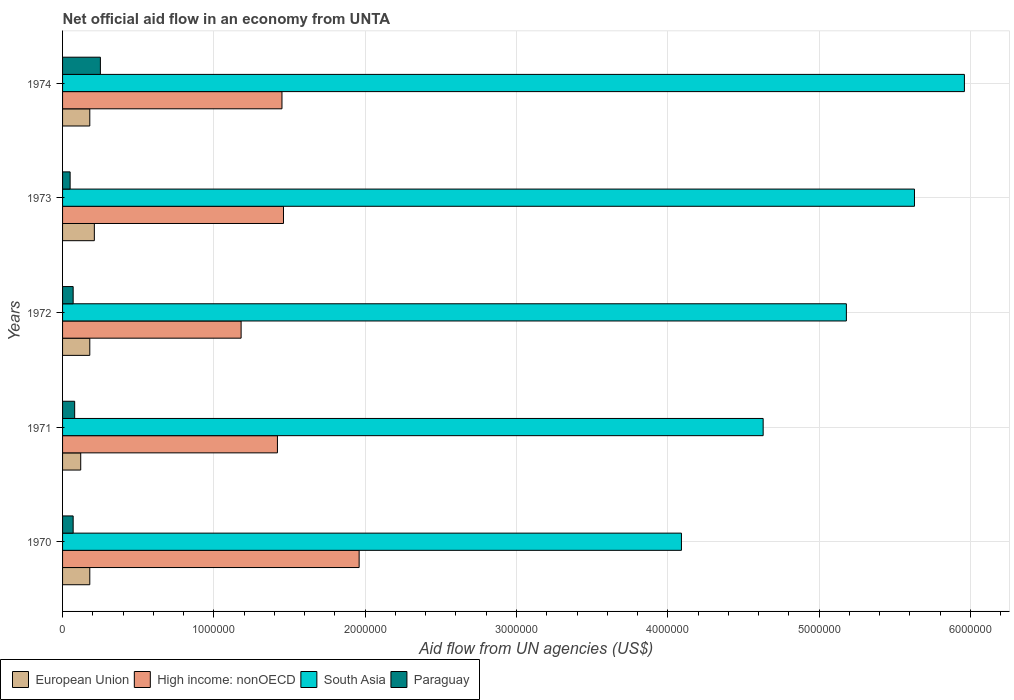How many different coloured bars are there?
Offer a terse response. 4. How many groups of bars are there?
Provide a succinct answer. 5. How many bars are there on the 5th tick from the top?
Provide a short and direct response. 4. What is the label of the 5th group of bars from the top?
Provide a short and direct response. 1970. In how many cases, is the number of bars for a given year not equal to the number of legend labels?
Your answer should be very brief. 0. Across all years, what is the maximum net official aid flow in South Asia?
Offer a terse response. 5.96e+06. In which year was the net official aid flow in European Union maximum?
Offer a terse response. 1973. In which year was the net official aid flow in South Asia minimum?
Keep it short and to the point. 1970. What is the total net official aid flow in South Asia in the graph?
Provide a succinct answer. 2.55e+07. What is the difference between the net official aid flow in High income: nonOECD in 1972 and that in 1974?
Your response must be concise. -2.70e+05. What is the difference between the net official aid flow in High income: nonOECD in 1970 and the net official aid flow in South Asia in 1972?
Your answer should be compact. -3.22e+06. What is the average net official aid flow in South Asia per year?
Give a very brief answer. 5.10e+06. In the year 1970, what is the difference between the net official aid flow in European Union and net official aid flow in South Asia?
Provide a short and direct response. -3.91e+06. What is the ratio of the net official aid flow in High income: nonOECD in 1971 to that in 1974?
Provide a succinct answer. 0.98. Is the difference between the net official aid flow in European Union in 1970 and 1972 greater than the difference between the net official aid flow in South Asia in 1970 and 1972?
Give a very brief answer. Yes. What is the difference between the highest and the second highest net official aid flow in Paraguay?
Your response must be concise. 1.70e+05. What is the difference between the highest and the lowest net official aid flow in High income: nonOECD?
Ensure brevity in your answer.  7.80e+05. In how many years, is the net official aid flow in Paraguay greater than the average net official aid flow in Paraguay taken over all years?
Keep it short and to the point. 1. Is the sum of the net official aid flow in South Asia in 1973 and 1974 greater than the maximum net official aid flow in Paraguay across all years?
Offer a terse response. Yes. Is it the case that in every year, the sum of the net official aid flow in High income: nonOECD and net official aid flow in South Asia is greater than the sum of net official aid flow in Paraguay and net official aid flow in European Union?
Provide a short and direct response. No. What does the 1st bar from the top in 1970 represents?
Your answer should be very brief. Paraguay. What does the 4th bar from the bottom in 1971 represents?
Provide a short and direct response. Paraguay. How many years are there in the graph?
Keep it short and to the point. 5. Are the values on the major ticks of X-axis written in scientific E-notation?
Offer a terse response. No. Does the graph contain grids?
Make the answer very short. Yes. Where does the legend appear in the graph?
Provide a short and direct response. Bottom left. What is the title of the graph?
Keep it short and to the point. Net official aid flow in an economy from UNTA. What is the label or title of the X-axis?
Your response must be concise. Aid flow from UN agencies (US$). What is the Aid flow from UN agencies (US$) in High income: nonOECD in 1970?
Your answer should be compact. 1.96e+06. What is the Aid flow from UN agencies (US$) of South Asia in 1970?
Offer a very short reply. 4.09e+06. What is the Aid flow from UN agencies (US$) of High income: nonOECD in 1971?
Provide a short and direct response. 1.42e+06. What is the Aid flow from UN agencies (US$) of South Asia in 1971?
Offer a very short reply. 4.63e+06. What is the Aid flow from UN agencies (US$) of Paraguay in 1971?
Offer a very short reply. 8.00e+04. What is the Aid flow from UN agencies (US$) in European Union in 1972?
Your answer should be compact. 1.80e+05. What is the Aid flow from UN agencies (US$) of High income: nonOECD in 1972?
Your answer should be compact. 1.18e+06. What is the Aid flow from UN agencies (US$) of South Asia in 1972?
Your response must be concise. 5.18e+06. What is the Aid flow from UN agencies (US$) of High income: nonOECD in 1973?
Provide a succinct answer. 1.46e+06. What is the Aid flow from UN agencies (US$) in South Asia in 1973?
Provide a short and direct response. 5.63e+06. What is the Aid flow from UN agencies (US$) in European Union in 1974?
Your response must be concise. 1.80e+05. What is the Aid flow from UN agencies (US$) in High income: nonOECD in 1974?
Make the answer very short. 1.45e+06. What is the Aid flow from UN agencies (US$) of South Asia in 1974?
Offer a terse response. 5.96e+06. What is the Aid flow from UN agencies (US$) of Paraguay in 1974?
Make the answer very short. 2.50e+05. Across all years, what is the maximum Aid flow from UN agencies (US$) in European Union?
Your answer should be very brief. 2.10e+05. Across all years, what is the maximum Aid flow from UN agencies (US$) in High income: nonOECD?
Give a very brief answer. 1.96e+06. Across all years, what is the maximum Aid flow from UN agencies (US$) of South Asia?
Ensure brevity in your answer.  5.96e+06. Across all years, what is the minimum Aid flow from UN agencies (US$) in European Union?
Keep it short and to the point. 1.20e+05. Across all years, what is the minimum Aid flow from UN agencies (US$) of High income: nonOECD?
Make the answer very short. 1.18e+06. Across all years, what is the minimum Aid flow from UN agencies (US$) in South Asia?
Ensure brevity in your answer.  4.09e+06. Across all years, what is the minimum Aid flow from UN agencies (US$) of Paraguay?
Your answer should be very brief. 5.00e+04. What is the total Aid flow from UN agencies (US$) of European Union in the graph?
Give a very brief answer. 8.70e+05. What is the total Aid flow from UN agencies (US$) in High income: nonOECD in the graph?
Provide a short and direct response. 7.47e+06. What is the total Aid flow from UN agencies (US$) of South Asia in the graph?
Provide a short and direct response. 2.55e+07. What is the total Aid flow from UN agencies (US$) in Paraguay in the graph?
Your answer should be compact. 5.20e+05. What is the difference between the Aid flow from UN agencies (US$) of High income: nonOECD in 1970 and that in 1971?
Ensure brevity in your answer.  5.40e+05. What is the difference between the Aid flow from UN agencies (US$) in South Asia in 1970 and that in 1971?
Offer a very short reply. -5.40e+05. What is the difference between the Aid flow from UN agencies (US$) in Paraguay in 1970 and that in 1971?
Give a very brief answer. -10000. What is the difference between the Aid flow from UN agencies (US$) of European Union in 1970 and that in 1972?
Your answer should be compact. 0. What is the difference between the Aid flow from UN agencies (US$) of High income: nonOECD in 1970 and that in 1972?
Offer a very short reply. 7.80e+05. What is the difference between the Aid flow from UN agencies (US$) of South Asia in 1970 and that in 1972?
Provide a short and direct response. -1.09e+06. What is the difference between the Aid flow from UN agencies (US$) of Paraguay in 1970 and that in 1972?
Provide a short and direct response. 0. What is the difference between the Aid flow from UN agencies (US$) in European Union in 1970 and that in 1973?
Your answer should be very brief. -3.00e+04. What is the difference between the Aid flow from UN agencies (US$) of High income: nonOECD in 1970 and that in 1973?
Provide a succinct answer. 5.00e+05. What is the difference between the Aid flow from UN agencies (US$) in South Asia in 1970 and that in 1973?
Offer a terse response. -1.54e+06. What is the difference between the Aid flow from UN agencies (US$) of High income: nonOECD in 1970 and that in 1974?
Provide a short and direct response. 5.10e+05. What is the difference between the Aid flow from UN agencies (US$) in South Asia in 1970 and that in 1974?
Provide a short and direct response. -1.87e+06. What is the difference between the Aid flow from UN agencies (US$) of Paraguay in 1970 and that in 1974?
Provide a short and direct response. -1.80e+05. What is the difference between the Aid flow from UN agencies (US$) in South Asia in 1971 and that in 1972?
Offer a terse response. -5.50e+05. What is the difference between the Aid flow from UN agencies (US$) of Paraguay in 1971 and that in 1972?
Your answer should be very brief. 10000. What is the difference between the Aid flow from UN agencies (US$) of European Union in 1971 and that in 1974?
Provide a succinct answer. -6.00e+04. What is the difference between the Aid flow from UN agencies (US$) of South Asia in 1971 and that in 1974?
Give a very brief answer. -1.33e+06. What is the difference between the Aid flow from UN agencies (US$) of High income: nonOECD in 1972 and that in 1973?
Your answer should be compact. -2.80e+05. What is the difference between the Aid flow from UN agencies (US$) of South Asia in 1972 and that in 1973?
Make the answer very short. -4.50e+05. What is the difference between the Aid flow from UN agencies (US$) of Paraguay in 1972 and that in 1973?
Your answer should be very brief. 2.00e+04. What is the difference between the Aid flow from UN agencies (US$) of South Asia in 1972 and that in 1974?
Offer a very short reply. -7.80e+05. What is the difference between the Aid flow from UN agencies (US$) of Paraguay in 1972 and that in 1974?
Your response must be concise. -1.80e+05. What is the difference between the Aid flow from UN agencies (US$) of High income: nonOECD in 1973 and that in 1974?
Offer a terse response. 10000. What is the difference between the Aid flow from UN agencies (US$) in South Asia in 1973 and that in 1974?
Offer a terse response. -3.30e+05. What is the difference between the Aid flow from UN agencies (US$) in European Union in 1970 and the Aid flow from UN agencies (US$) in High income: nonOECD in 1971?
Ensure brevity in your answer.  -1.24e+06. What is the difference between the Aid flow from UN agencies (US$) in European Union in 1970 and the Aid flow from UN agencies (US$) in South Asia in 1971?
Provide a succinct answer. -4.45e+06. What is the difference between the Aid flow from UN agencies (US$) in European Union in 1970 and the Aid flow from UN agencies (US$) in Paraguay in 1971?
Keep it short and to the point. 1.00e+05. What is the difference between the Aid flow from UN agencies (US$) of High income: nonOECD in 1970 and the Aid flow from UN agencies (US$) of South Asia in 1971?
Make the answer very short. -2.67e+06. What is the difference between the Aid flow from UN agencies (US$) of High income: nonOECD in 1970 and the Aid flow from UN agencies (US$) of Paraguay in 1971?
Provide a succinct answer. 1.88e+06. What is the difference between the Aid flow from UN agencies (US$) of South Asia in 1970 and the Aid flow from UN agencies (US$) of Paraguay in 1971?
Make the answer very short. 4.01e+06. What is the difference between the Aid flow from UN agencies (US$) in European Union in 1970 and the Aid flow from UN agencies (US$) in South Asia in 1972?
Provide a short and direct response. -5.00e+06. What is the difference between the Aid flow from UN agencies (US$) of High income: nonOECD in 1970 and the Aid flow from UN agencies (US$) of South Asia in 1972?
Ensure brevity in your answer.  -3.22e+06. What is the difference between the Aid flow from UN agencies (US$) in High income: nonOECD in 1970 and the Aid flow from UN agencies (US$) in Paraguay in 1972?
Your response must be concise. 1.89e+06. What is the difference between the Aid flow from UN agencies (US$) of South Asia in 1970 and the Aid flow from UN agencies (US$) of Paraguay in 1972?
Keep it short and to the point. 4.02e+06. What is the difference between the Aid flow from UN agencies (US$) of European Union in 1970 and the Aid flow from UN agencies (US$) of High income: nonOECD in 1973?
Ensure brevity in your answer.  -1.28e+06. What is the difference between the Aid flow from UN agencies (US$) in European Union in 1970 and the Aid flow from UN agencies (US$) in South Asia in 1973?
Offer a terse response. -5.45e+06. What is the difference between the Aid flow from UN agencies (US$) in European Union in 1970 and the Aid flow from UN agencies (US$) in Paraguay in 1973?
Ensure brevity in your answer.  1.30e+05. What is the difference between the Aid flow from UN agencies (US$) of High income: nonOECD in 1970 and the Aid flow from UN agencies (US$) of South Asia in 1973?
Offer a very short reply. -3.67e+06. What is the difference between the Aid flow from UN agencies (US$) of High income: nonOECD in 1970 and the Aid flow from UN agencies (US$) of Paraguay in 1973?
Offer a very short reply. 1.91e+06. What is the difference between the Aid flow from UN agencies (US$) of South Asia in 1970 and the Aid flow from UN agencies (US$) of Paraguay in 1973?
Your answer should be compact. 4.04e+06. What is the difference between the Aid flow from UN agencies (US$) in European Union in 1970 and the Aid flow from UN agencies (US$) in High income: nonOECD in 1974?
Keep it short and to the point. -1.27e+06. What is the difference between the Aid flow from UN agencies (US$) in European Union in 1970 and the Aid flow from UN agencies (US$) in South Asia in 1974?
Your answer should be compact. -5.78e+06. What is the difference between the Aid flow from UN agencies (US$) in High income: nonOECD in 1970 and the Aid flow from UN agencies (US$) in Paraguay in 1974?
Offer a very short reply. 1.71e+06. What is the difference between the Aid flow from UN agencies (US$) in South Asia in 1970 and the Aid flow from UN agencies (US$) in Paraguay in 1974?
Provide a short and direct response. 3.84e+06. What is the difference between the Aid flow from UN agencies (US$) in European Union in 1971 and the Aid flow from UN agencies (US$) in High income: nonOECD in 1972?
Your answer should be very brief. -1.06e+06. What is the difference between the Aid flow from UN agencies (US$) in European Union in 1971 and the Aid flow from UN agencies (US$) in South Asia in 1972?
Give a very brief answer. -5.06e+06. What is the difference between the Aid flow from UN agencies (US$) in High income: nonOECD in 1971 and the Aid flow from UN agencies (US$) in South Asia in 1972?
Your answer should be very brief. -3.76e+06. What is the difference between the Aid flow from UN agencies (US$) of High income: nonOECD in 1971 and the Aid flow from UN agencies (US$) of Paraguay in 1972?
Your answer should be compact. 1.35e+06. What is the difference between the Aid flow from UN agencies (US$) in South Asia in 1971 and the Aid flow from UN agencies (US$) in Paraguay in 1972?
Keep it short and to the point. 4.56e+06. What is the difference between the Aid flow from UN agencies (US$) of European Union in 1971 and the Aid flow from UN agencies (US$) of High income: nonOECD in 1973?
Make the answer very short. -1.34e+06. What is the difference between the Aid flow from UN agencies (US$) in European Union in 1971 and the Aid flow from UN agencies (US$) in South Asia in 1973?
Your answer should be compact. -5.51e+06. What is the difference between the Aid flow from UN agencies (US$) of High income: nonOECD in 1971 and the Aid flow from UN agencies (US$) of South Asia in 1973?
Offer a terse response. -4.21e+06. What is the difference between the Aid flow from UN agencies (US$) of High income: nonOECD in 1971 and the Aid flow from UN agencies (US$) of Paraguay in 1973?
Your answer should be compact. 1.37e+06. What is the difference between the Aid flow from UN agencies (US$) of South Asia in 1971 and the Aid flow from UN agencies (US$) of Paraguay in 1973?
Offer a terse response. 4.58e+06. What is the difference between the Aid flow from UN agencies (US$) in European Union in 1971 and the Aid flow from UN agencies (US$) in High income: nonOECD in 1974?
Provide a succinct answer. -1.33e+06. What is the difference between the Aid flow from UN agencies (US$) of European Union in 1971 and the Aid flow from UN agencies (US$) of South Asia in 1974?
Give a very brief answer. -5.84e+06. What is the difference between the Aid flow from UN agencies (US$) of European Union in 1971 and the Aid flow from UN agencies (US$) of Paraguay in 1974?
Your answer should be compact. -1.30e+05. What is the difference between the Aid flow from UN agencies (US$) in High income: nonOECD in 1971 and the Aid flow from UN agencies (US$) in South Asia in 1974?
Your answer should be very brief. -4.54e+06. What is the difference between the Aid flow from UN agencies (US$) in High income: nonOECD in 1971 and the Aid flow from UN agencies (US$) in Paraguay in 1974?
Provide a short and direct response. 1.17e+06. What is the difference between the Aid flow from UN agencies (US$) in South Asia in 1971 and the Aid flow from UN agencies (US$) in Paraguay in 1974?
Your answer should be very brief. 4.38e+06. What is the difference between the Aid flow from UN agencies (US$) in European Union in 1972 and the Aid flow from UN agencies (US$) in High income: nonOECD in 1973?
Your answer should be very brief. -1.28e+06. What is the difference between the Aid flow from UN agencies (US$) in European Union in 1972 and the Aid flow from UN agencies (US$) in South Asia in 1973?
Offer a terse response. -5.45e+06. What is the difference between the Aid flow from UN agencies (US$) in European Union in 1972 and the Aid flow from UN agencies (US$) in Paraguay in 1973?
Your answer should be compact. 1.30e+05. What is the difference between the Aid flow from UN agencies (US$) of High income: nonOECD in 1972 and the Aid flow from UN agencies (US$) of South Asia in 1973?
Provide a succinct answer. -4.45e+06. What is the difference between the Aid flow from UN agencies (US$) in High income: nonOECD in 1972 and the Aid flow from UN agencies (US$) in Paraguay in 1973?
Your response must be concise. 1.13e+06. What is the difference between the Aid flow from UN agencies (US$) in South Asia in 1972 and the Aid flow from UN agencies (US$) in Paraguay in 1973?
Offer a very short reply. 5.13e+06. What is the difference between the Aid flow from UN agencies (US$) in European Union in 1972 and the Aid flow from UN agencies (US$) in High income: nonOECD in 1974?
Your answer should be very brief. -1.27e+06. What is the difference between the Aid flow from UN agencies (US$) of European Union in 1972 and the Aid flow from UN agencies (US$) of South Asia in 1974?
Make the answer very short. -5.78e+06. What is the difference between the Aid flow from UN agencies (US$) of High income: nonOECD in 1972 and the Aid flow from UN agencies (US$) of South Asia in 1974?
Keep it short and to the point. -4.78e+06. What is the difference between the Aid flow from UN agencies (US$) in High income: nonOECD in 1972 and the Aid flow from UN agencies (US$) in Paraguay in 1974?
Your response must be concise. 9.30e+05. What is the difference between the Aid flow from UN agencies (US$) in South Asia in 1972 and the Aid flow from UN agencies (US$) in Paraguay in 1974?
Your answer should be very brief. 4.93e+06. What is the difference between the Aid flow from UN agencies (US$) of European Union in 1973 and the Aid flow from UN agencies (US$) of High income: nonOECD in 1974?
Your answer should be very brief. -1.24e+06. What is the difference between the Aid flow from UN agencies (US$) of European Union in 1973 and the Aid flow from UN agencies (US$) of South Asia in 1974?
Provide a succinct answer. -5.75e+06. What is the difference between the Aid flow from UN agencies (US$) in European Union in 1973 and the Aid flow from UN agencies (US$) in Paraguay in 1974?
Your response must be concise. -4.00e+04. What is the difference between the Aid flow from UN agencies (US$) of High income: nonOECD in 1973 and the Aid flow from UN agencies (US$) of South Asia in 1974?
Keep it short and to the point. -4.50e+06. What is the difference between the Aid flow from UN agencies (US$) of High income: nonOECD in 1973 and the Aid flow from UN agencies (US$) of Paraguay in 1974?
Keep it short and to the point. 1.21e+06. What is the difference between the Aid flow from UN agencies (US$) in South Asia in 1973 and the Aid flow from UN agencies (US$) in Paraguay in 1974?
Keep it short and to the point. 5.38e+06. What is the average Aid flow from UN agencies (US$) in European Union per year?
Offer a terse response. 1.74e+05. What is the average Aid flow from UN agencies (US$) in High income: nonOECD per year?
Give a very brief answer. 1.49e+06. What is the average Aid flow from UN agencies (US$) of South Asia per year?
Your response must be concise. 5.10e+06. What is the average Aid flow from UN agencies (US$) in Paraguay per year?
Keep it short and to the point. 1.04e+05. In the year 1970, what is the difference between the Aid flow from UN agencies (US$) of European Union and Aid flow from UN agencies (US$) of High income: nonOECD?
Your answer should be compact. -1.78e+06. In the year 1970, what is the difference between the Aid flow from UN agencies (US$) of European Union and Aid flow from UN agencies (US$) of South Asia?
Make the answer very short. -3.91e+06. In the year 1970, what is the difference between the Aid flow from UN agencies (US$) of High income: nonOECD and Aid flow from UN agencies (US$) of South Asia?
Offer a very short reply. -2.13e+06. In the year 1970, what is the difference between the Aid flow from UN agencies (US$) of High income: nonOECD and Aid flow from UN agencies (US$) of Paraguay?
Provide a short and direct response. 1.89e+06. In the year 1970, what is the difference between the Aid flow from UN agencies (US$) in South Asia and Aid flow from UN agencies (US$) in Paraguay?
Your answer should be very brief. 4.02e+06. In the year 1971, what is the difference between the Aid flow from UN agencies (US$) in European Union and Aid flow from UN agencies (US$) in High income: nonOECD?
Your response must be concise. -1.30e+06. In the year 1971, what is the difference between the Aid flow from UN agencies (US$) of European Union and Aid flow from UN agencies (US$) of South Asia?
Provide a succinct answer. -4.51e+06. In the year 1971, what is the difference between the Aid flow from UN agencies (US$) in High income: nonOECD and Aid flow from UN agencies (US$) in South Asia?
Your response must be concise. -3.21e+06. In the year 1971, what is the difference between the Aid flow from UN agencies (US$) in High income: nonOECD and Aid flow from UN agencies (US$) in Paraguay?
Your response must be concise. 1.34e+06. In the year 1971, what is the difference between the Aid flow from UN agencies (US$) in South Asia and Aid flow from UN agencies (US$) in Paraguay?
Offer a terse response. 4.55e+06. In the year 1972, what is the difference between the Aid flow from UN agencies (US$) in European Union and Aid flow from UN agencies (US$) in High income: nonOECD?
Your response must be concise. -1.00e+06. In the year 1972, what is the difference between the Aid flow from UN agencies (US$) of European Union and Aid flow from UN agencies (US$) of South Asia?
Offer a very short reply. -5.00e+06. In the year 1972, what is the difference between the Aid flow from UN agencies (US$) of High income: nonOECD and Aid flow from UN agencies (US$) of South Asia?
Offer a very short reply. -4.00e+06. In the year 1972, what is the difference between the Aid flow from UN agencies (US$) in High income: nonOECD and Aid flow from UN agencies (US$) in Paraguay?
Give a very brief answer. 1.11e+06. In the year 1972, what is the difference between the Aid flow from UN agencies (US$) of South Asia and Aid flow from UN agencies (US$) of Paraguay?
Offer a very short reply. 5.11e+06. In the year 1973, what is the difference between the Aid flow from UN agencies (US$) in European Union and Aid flow from UN agencies (US$) in High income: nonOECD?
Ensure brevity in your answer.  -1.25e+06. In the year 1973, what is the difference between the Aid flow from UN agencies (US$) in European Union and Aid flow from UN agencies (US$) in South Asia?
Your answer should be compact. -5.42e+06. In the year 1973, what is the difference between the Aid flow from UN agencies (US$) in European Union and Aid flow from UN agencies (US$) in Paraguay?
Make the answer very short. 1.60e+05. In the year 1973, what is the difference between the Aid flow from UN agencies (US$) of High income: nonOECD and Aid flow from UN agencies (US$) of South Asia?
Ensure brevity in your answer.  -4.17e+06. In the year 1973, what is the difference between the Aid flow from UN agencies (US$) of High income: nonOECD and Aid flow from UN agencies (US$) of Paraguay?
Provide a succinct answer. 1.41e+06. In the year 1973, what is the difference between the Aid flow from UN agencies (US$) in South Asia and Aid flow from UN agencies (US$) in Paraguay?
Give a very brief answer. 5.58e+06. In the year 1974, what is the difference between the Aid flow from UN agencies (US$) of European Union and Aid flow from UN agencies (US$) of High income: nonOECD?
Make the answer very short. -1.27e+06. In the year 1974, what is the difference between the Aid flow from UN agencies (US$) of European Union and Aid flow from UN agencies (US$) of South Asia?
Your response must be concise. -5.78e+06. In the year 1974, what is the difference between the Aid flow from UN agencies (US$) in High income: nonOECD and Aid flow from UN agencies (US$) in South Asia?
Your response must be concise. -4.51e+06. In the year 1974, what is the difference between the Aid flow from UN agencies (US$) of High income: nonOECD and Aid flow from UN agencies (US$) of Paraguay?
Provide a succinct answer. 1.20e+06. In the year 1974, what is the difference between the Aid flow from UN agencies (US$) in South Asia and Aid flow from UN agencies (US$) in Paraguay?
Keep it short and to the point. 5.71e+06. What is the ratio of the Aid flow from UN agencies (US$) in High income: nonOECD in 1970 to that in 1971?
Offer a very short reply. 1.38. What is the ratio of the Aid flow from UN agencies (US$) in South Asia in 1970 to that in 1971?
Make the answer very short. 0.88. What is the ratio of the Aid flow from UN agencies (US$) of Paraguay in 1970 to that in 1971?
Keep it short and to the point. 0.88. What is the ratio of the Aid flow from UN agencies (US$) in High income: nonOECD in 1970 to that in 1972?
Your answer should be very brief. 1.66. What is the ratio of the Aid flow from UN agencies (US$) in South Asia in 1970 to that in 1972?
Offer a terse response. 0.79. What is the ratio of the Aid flow from UN agencies (US$) of European Union in 1970 to that in 1973?
Offer a terse response. 0.86. What is the ratio of the Aid flow from UN agencies (US$) in High income: nonOECD in 1970 to that in 1973?
Offer a very short reply. 1.34. What is the ratio of the Aid flow from UN agencies (US$) of South Asia in 1970 to that in 1973?
Give a very brief answer. 0.73. What is the ratio of the Aid flow from UN agencies (US$) of High income: nonOECD in 1970 to that in 1974?
Offer a very short reply. 1.35. What is the ratio of the Aid flow from UN agencies (US$) of South Asia in 1970 to that in 1974?
Keep it short and to the point. 0.69. What is the ratio of the Aid flow from UN agencies (US$) of Paraguay in 1970 to that in 1974?
Make the answer very short. 0.28. What is the ratio of the Aid flow from UN agencies (US$) in High income: nonOECD in 1971 to that in 1972?
Make the answer very short. 1.2. What is the ratio of the Aid flow from UN agencies (US$) of South Asia in 1971 to that in 1972?
Your response must be concise. 0.89. What is the ratio of the Aid flow from UN agencies (US$) in High income: nonOECD in 1971 to that in 1973?
Provide a short and direct response. 0.97. What is the ratio of the Aid flow from UN agencies (US$) in South Asia in 1971 to that in 1973?
Your response must be concise. 0.82. What is the ratio of the Aid flow from UN agencies (US$) in European Union in 1971 to that in 1974?
Provide a succinct answer. 0.67. What is the ratio of the Aid flow from UN agencies (US$) of High income: nonOECD in 1971 to that in 1974?
Your answer should be compact. 0.98. What is the ratio of the Aid flow from UN agencies (US$) in South Asia in 1971 to that in 1974?
Your answer should be compact. 0.78. What is the ratio of the Aid flow from UN agencies (US$) of Paraguay in 1971 to that in 1974?
Your answer should be compact. 0.32. What is the ratio of the Aid flow from UN agencies (US$) of European Union in 1972 to that in 1973?
Your answer should be compact. 0.86. What is the ratio of the Aid flow from UN agencies (US$) of High income: nonOECD in 1972 to that in 1973?
Your response must be concise. 0.81. What is the ratio of the Aid flow from UN agencies (US$) of South Asia in 1972 to that in 1973?
Keep it short and to the point. 0.92. What is the ratio of the Aid flow from UN agencies (US$) in European Union in 1972 to that in 1974?
Give a very brief answer. 1. What is the ratio of the Aid flow from UN agencies (US$) in High income: nonOECD in 1972 to that in 1974?
Your response must be concise. 0.81. What is the ratio of the Aid flow from UN agencies (US$) in South Asia in 1972 to that in 1974?
Provide a short and direct response. 0.87. What is the ratio of the Aid flow from UN agencies (US$) in Paraguay in 1972 to that in 1974?
Give a very brief answer. 0.28. What is the ratio of the Aid flow from UN agencies (US$) in High income: nonOECD in 1973 to that in 1974?
Your answer should be compact. 1.01. What is the ratio of the Aid flow from UN agencies (US$) of South Asia in 1973 to that in 1974?
Offer a very short reply. 0.94. What is the difference between the highest and the second highest Aid flow from UN agencies (US$) in High income: nonOECD?
Provide a short and direct response. 5.00e+05. What is the difference between the highest and the second highest Aid flow from UN agencies (US$) in South Asia?
Ensure brevity in your answer.  3.30e+05. What is the difference between the highest and the second highest Aid flow from UN agencies (US$) of Paraguay?
Provide a short and direct response. 1.70e+05. What is the difference between the highest and the lowest Aid flow from UN agencies (US$) of European Union?
Offer a terse response. 9.00e+04. What is the difference between the highest and the lowest Aid flow from UN agencies (US$) in High income: nonOECD?
Give a very brief answer. 7.80e+05. What is the difference between the highest and the lowest Aid flow from UN agencies (US$) in South Asia?
Offer a terse response. 1.87e+06. What is the difference between the highest and the lowest Aid flow from UN agencies (US$) of Paraguay?
Ensure brevity in your answer.  2.00e+05. 